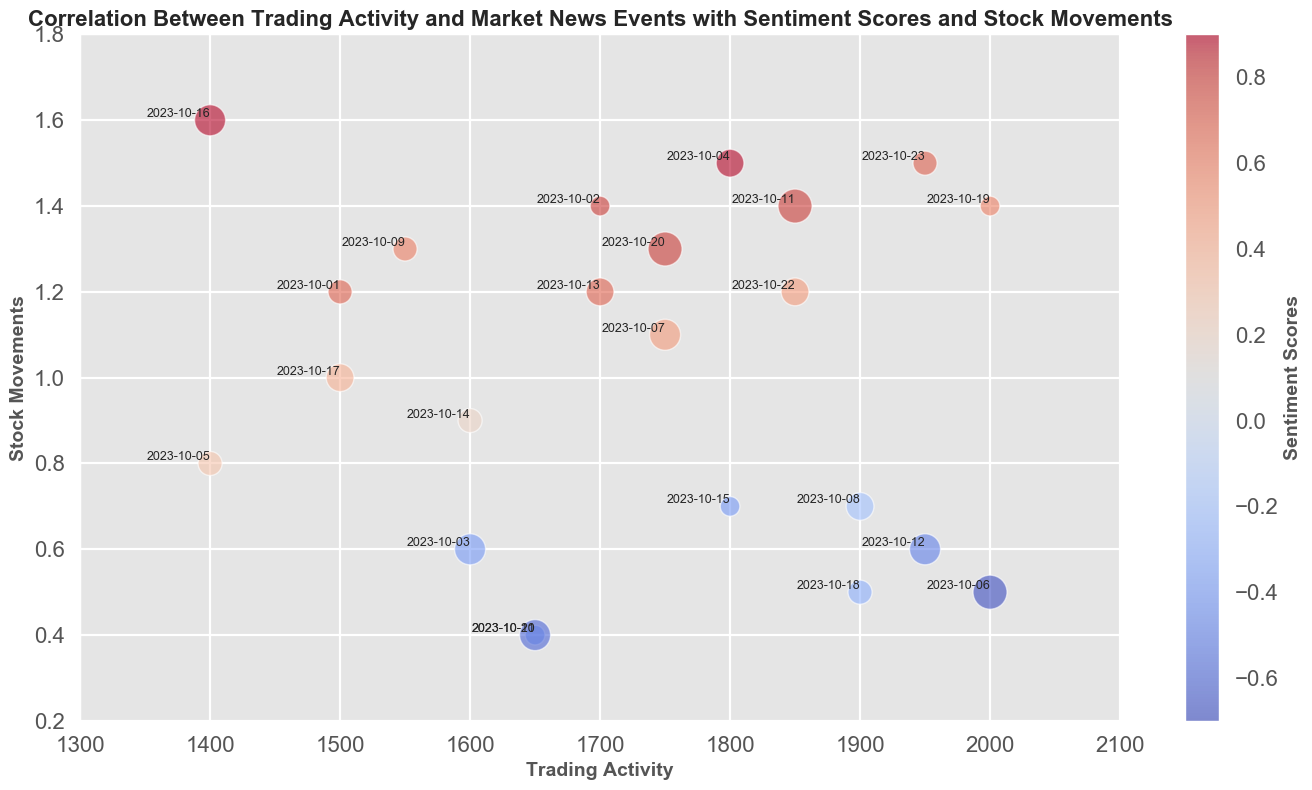Which date had the highest trading activity? To find the date with the highest trading activity, look at the x-axis and identify the largest value for trading activity which is represented by the position furthest to the right. The corresponding date label is "2023-10-06".
Answer: 2023-10-06 How did the stock movement on 2023-10-04 compare to that on 2023-10-19? Identify the stock movements on the y-axis for both dates by locating their labels. The stock movement for 2023-10-04 is 1.5, whereas for 2023-10-19 it is 1.4. Since 1.5 is greater than 1.4, the stock movement on 2023-10-04 is higher.
Answer: 2023-10-04 Which date had the largest bubble? What does it represent? The largest bubble represents a high number of market news events. Visually inspect for the largest bubble size on the plot, which corresponds to "2023-10-06" with a value of 6 for market news events.
Answer: 2023-10-06 represents 6 market news events What is the sentiment score on the date with the highest trading activity? Identify the date with the highest trading activity, which is 2023-10-06. Look at the color of the bubble associated with this date on the sentiment score color scale. The color indicates a sentiment score of -0.7.
Answer: -0.7 If you sum the trading activity of 2023-10-01 and 2023-10-05, what do you get? Look at the x-axis values for these dates. The trading activities are 1500 and 1400 respectively. The sum is 1500 + 1400 = 2900.
Answer: 2900 Which date had the most negative sentiment score and what was the stock movement on that date? Examine the color of the bubbles to find the one with the deepest blue, indicating the most negative sentiment score of -0.7, which is on 2023-10-06. The stock movement on this date is 0.5.
Answer: 2023-10-06, 0.5 On which date was the trading activity closest to 1650? Find the bubble whose x-axis value is nearest to 1650. Multiple dates (2023-10-03, 2023-10-10, 2023-10-21) are close, but the exact match is "2023-10-10".
Answer: 2023-10-10 Which dates had bubbles with the same trading activity but different stock movements? Look for dates that align vertically, indicating the same trading activity but differing y-axis values. For example, 2023-10-01 and 2023-10-17 both have 1500 trading activity but 1.2 and 1.0 stock movements respectively.
Answer: 2023-10-01 and 2023-10-17 